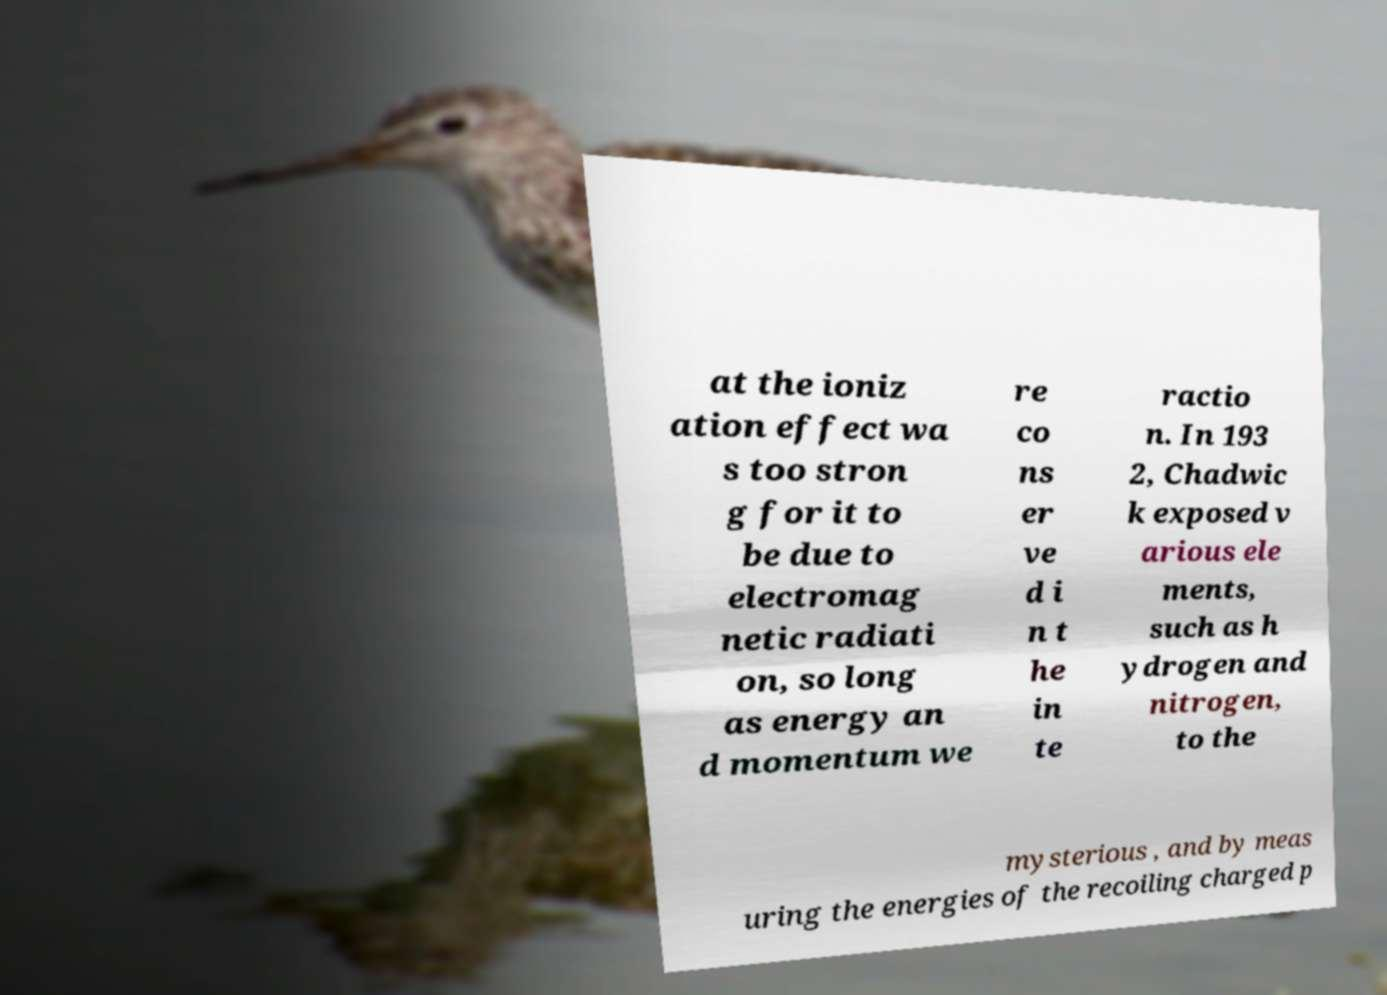Please identify and transcribe the text found in this image. at the ioniz ation effect wa s too stron g for it to be due to electromag netic radiati on, so long as energy an d momentum we re co ns er ve d i n t he in te ractio n. In 193 2, Chadwic k exposed v arious ele ments, such as h ydrogen and nitrogen, to the mysterious , and by meas uring the energies of the recoiling charged p 